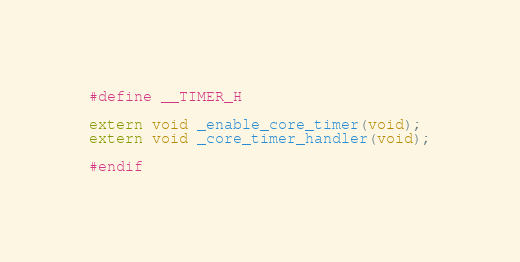Convert code to text. <code><loc_0><loc_0><loc_500><loc_500><_C_>#define __TIMER_H

extern void _enable_core_timer(void);
extern void _core_timer_handler(void);

#endif
</code> 